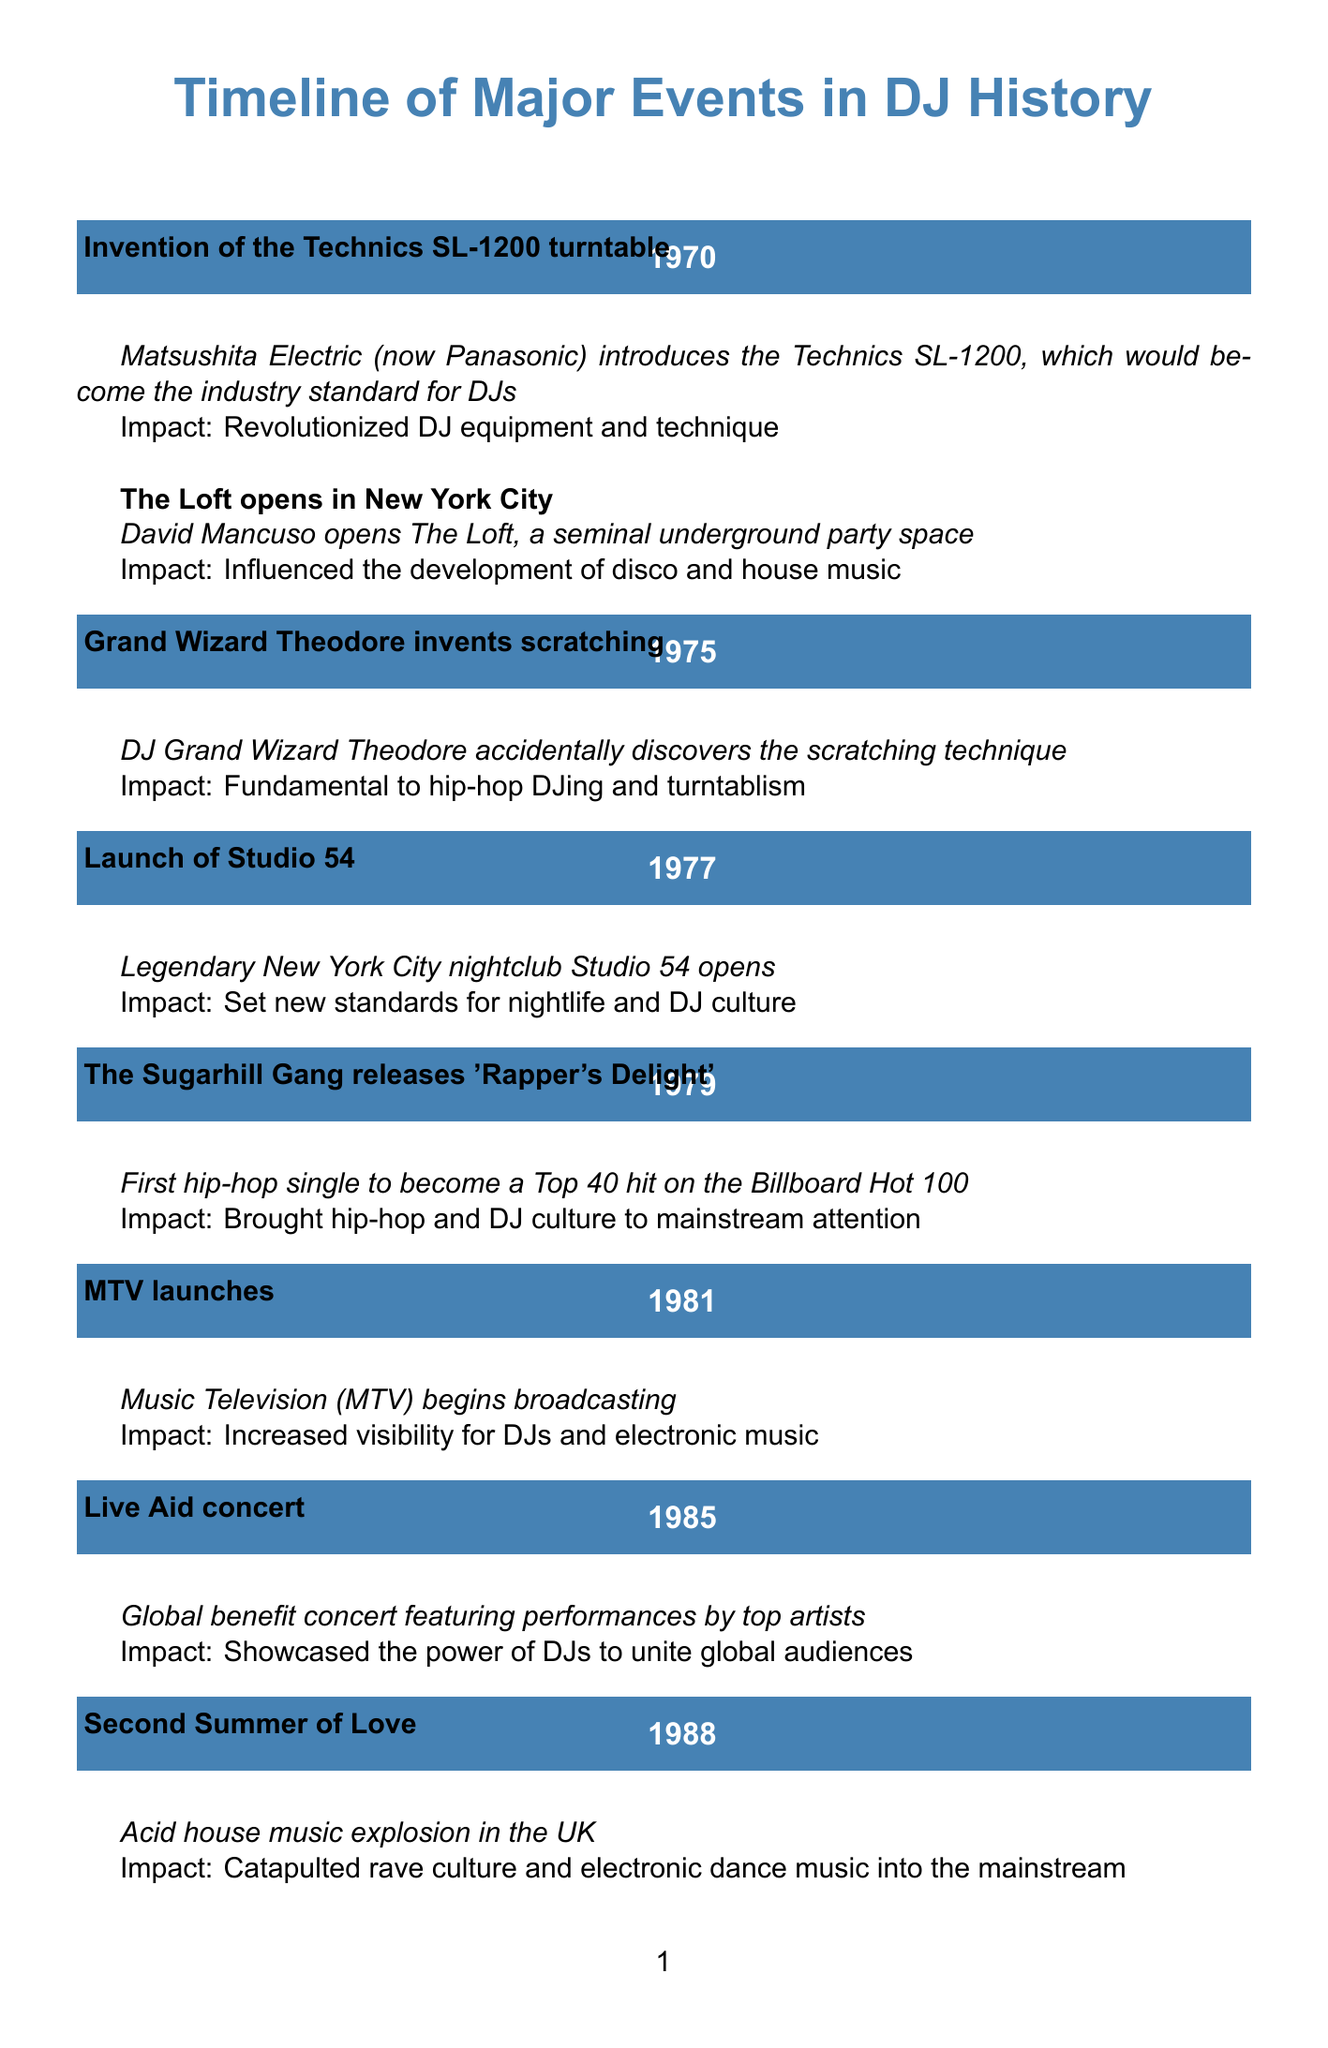what year was the Technics SL-1200 invented? The document states that the Technics SL-1200 turntable was invented in 1970.
Answer: 1970 who opened The Loft? According to the document, David Mancuso opened The Loft in New York City.
Answer: David Mancuso what significant event happened in 1988? The document mentions that the Second Summer of Love, an acid house music explosion in the UK, occurred in 1988.
Answer: Second Summer of Love how did the launch of MTV impact DJs? The document notes that MTV increased visibility for DJs and electronic music.
Answer: Increased visibility for DJs which digital vinyl system was released in 2006? The Serato Scratch Live was released in 2006 as per the document.
Answer: Serato Scratch Live what was the impact of the 2020 pandemic on DJ culture? The document states that the pandemic led to a surge in livestreamed DJ sets, accelerating virtual performances and online DJ communities.
Answer: Surge in livestreamed DJ sets in which city did the Ministry of Sound open? The document specifies that the Ministry of Sound opened in London.
Answer: London how many events are listed for the year 1995? The document lists one event for the year 1995, which is the development of Final Scratch.
Answer: One event 